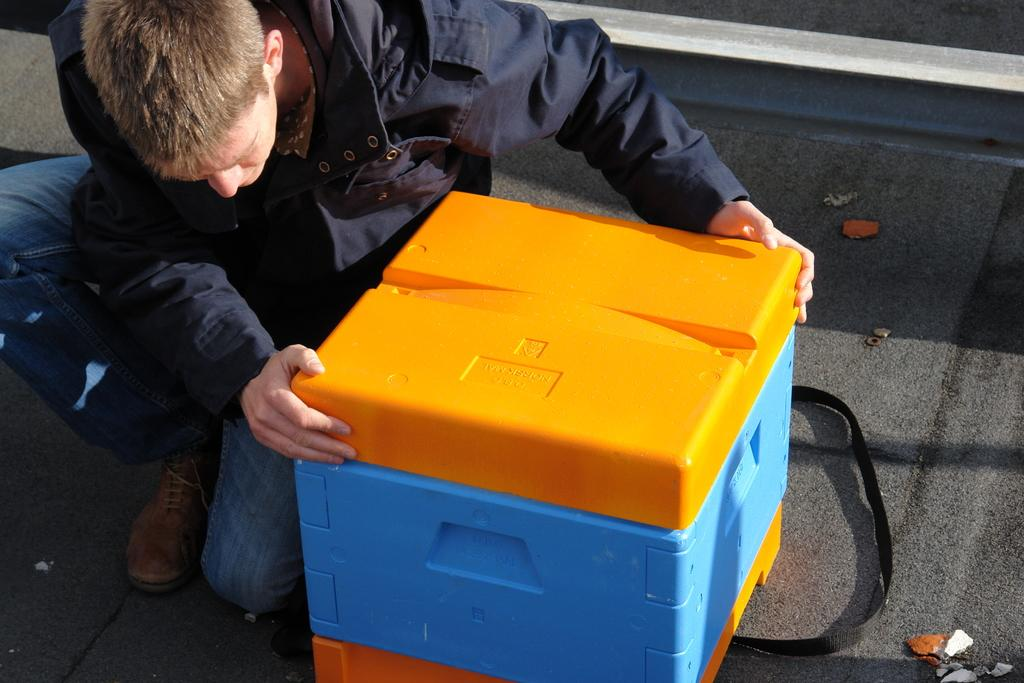What is present in the image? There is a man in the image. What is the man holding in the image? The man is holding a box with his hands. What type of silk is the man using to catch the pest in the image? There is no silk or pest present in the image. How many pigs can be seen in the image? There are no pigs present in the image. 